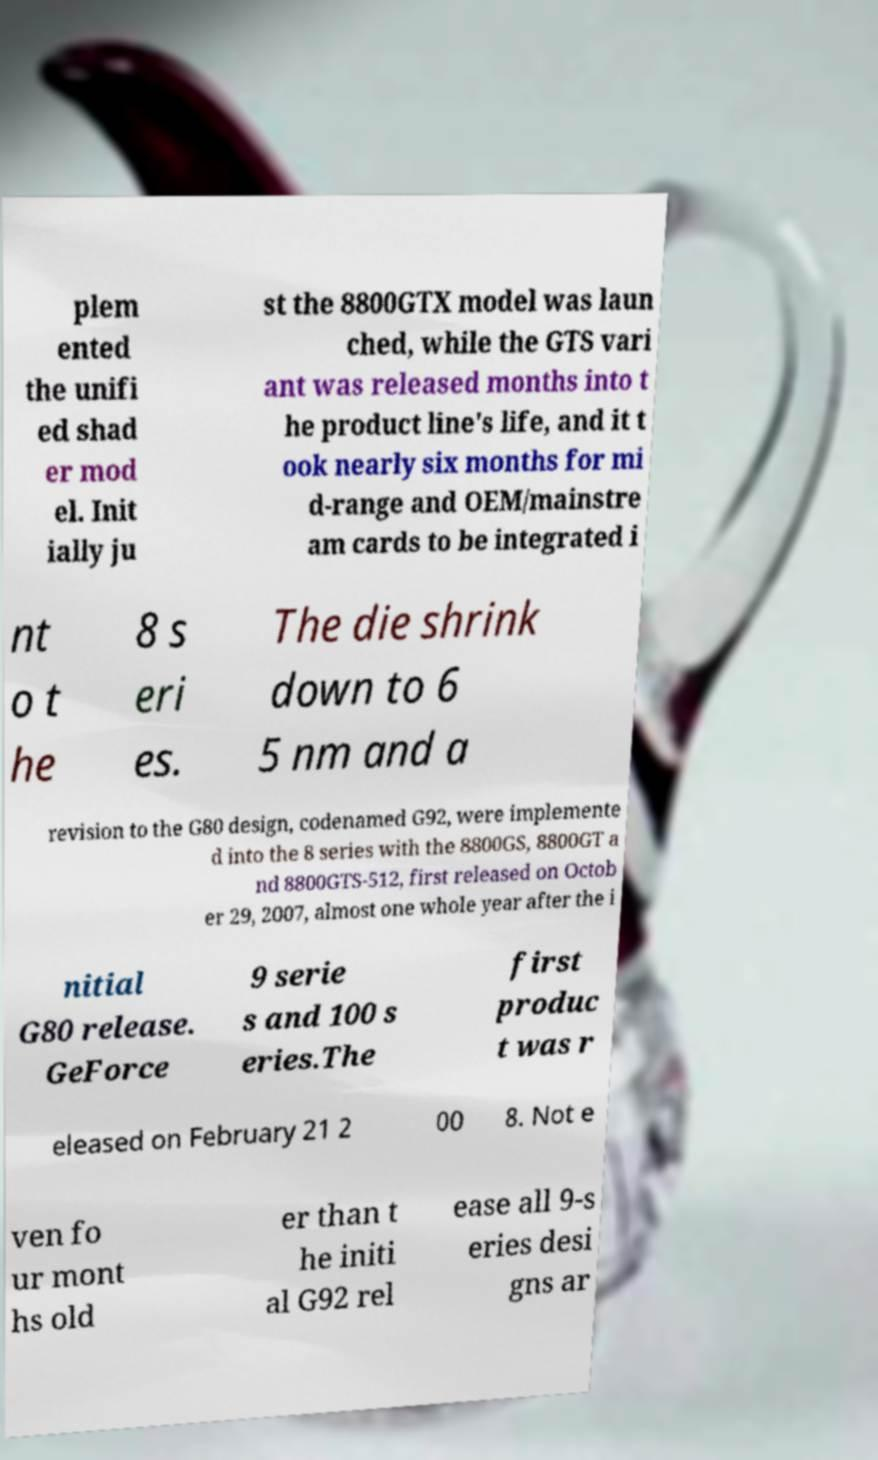There's text embedded in this image that I need extracted. Can you transcribe it verbatim? plem ented the unifi ed shad er mod el. Init ially ju st the 8800GTX model was laun ched, while the GTS vari ant was released months into t he product line's life, and it t ook nearly six months for mi d-range and OEM/mainstre am cards to be integrated i nt o t he 8 s eri es. The die shrink down to 6 5 nm and a revision to the G80 design, codenamed G92, were implemente d into the 8 series with the 8800GS, 8800GT a nd 8800GTS-512, first released on Octob er 29, 2007, almost one whole year after the i nitial G80 release. GeForce 9 serie s and 100 s eries.The first produc t was r eleased on February 21 2 00 8. Not e ven fo ur mont hs old er than t he initi al G92 rel ease all 9-s eries desi gns ar 